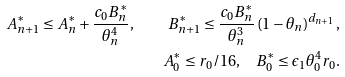Convert formula to latex. <formula><loc_0><loc_0><loc_500><loc_500>A _ { n + 1 } ^ { * } \leq A _ { n } ^ { * } + \frac { c _ { 0 } B _ { n } ^ { * } } { \theta _ { n } ^ { 4 } } , \quad B _ { n + 1 } ^ { * } \leq \frac { c _ { 0 } B _ { n } ^ { * } } { \theta _ { n } ^ { 3 } } \left ( 1 - \theta _ { n } \right ) ^ { d _ { n + 1 } } , \\ A _ { 0 } ^ { * } \leq r _ { 0 } / 1 6 , \quad B _ { 0 } ^ { * } \leq \epsilon _ { 1 } \theta _ { 0 } ^ { 4 } r _ { 0 } .</formula> 